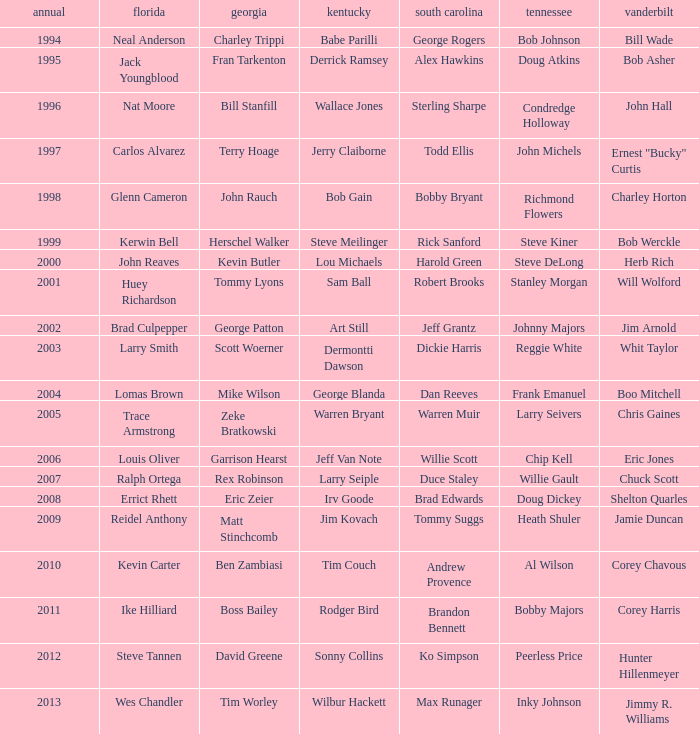What is the Tennessee with a Kentucky of Larry Seiple Willie Gault. 